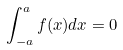<formula> <loc_0><loc_0><loc_500><loc_500>\int _ { - a } ^ { a } f ( x ) d x = 0</formula> 